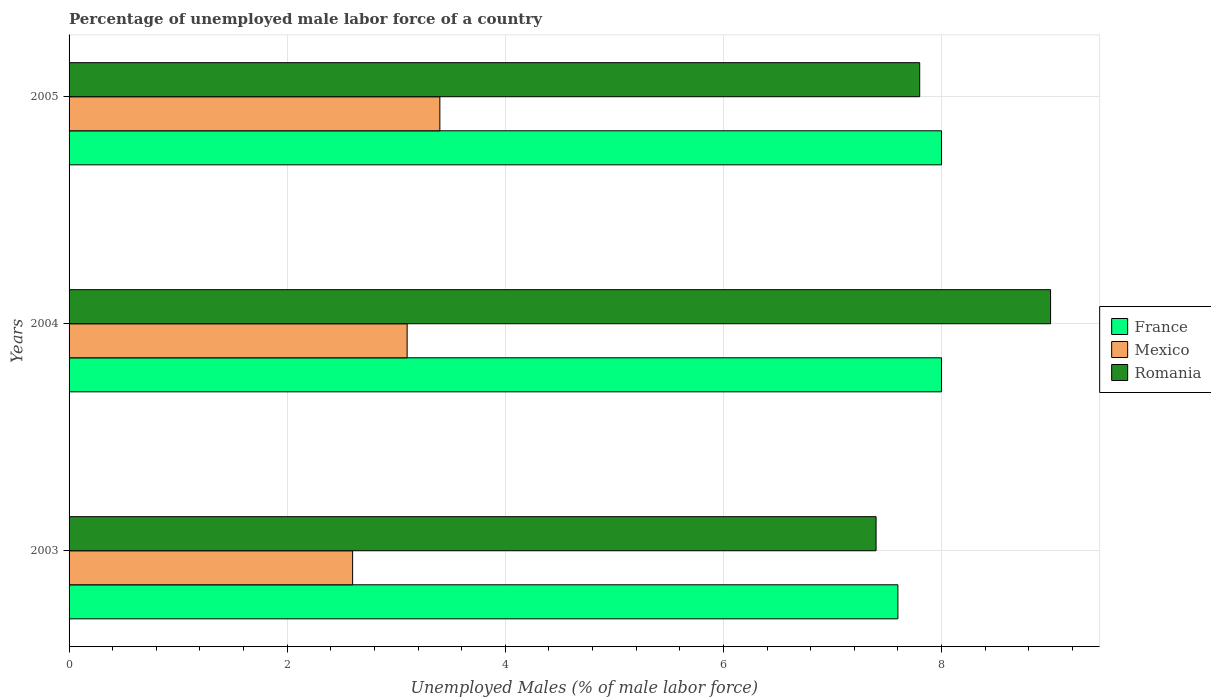How many different coloured bars are there?
Your answer should be very brief. 3. How many groups of bars are there?
Your response must be concise. 3. Are the number of bars per tick equal to the number of legend labels?
Your response must be concise. Yes. Are the number of bars on each tick of the Y-axis equal?
Give a very brief answer. Yes. In how many cases, is the number of bars for a given year not equal to the number of legend labels?
Offer a terse response. 0. What is the percentage of unemployed male labor force in Mexico in 2003?
Your answer should be compact. 2.6. Across all years, what is the minimum percentage of unemployed male labor force in Mexico?
Offer a very short reply. 2.6. In which year was the percentage of unemployed male labor force in Mexico maximum?
Keep it short and to the point. 2005. In which year was the percentage of unemployed male labor force in France minimum?
Your response must be concise. 2003. What is the total percentage of unemployed male labor force in France in the graph?
Ensure brevity in your answer.  23.6. What is the difference between the percentage of unemployed male labor force in Mexico in 2003 and that in 2005?
Your response must be concise. -0.8. What is the difference between the percentage of unemployed male labor force in Mexico in 2004 and the percentage of unemployed male labor force in Romania in 2003?
Keep it short and to the point. -4.3. What is the average percentage of unemployed male labor force in Mexico per year?
Offer a very short reply. 3.03. In the year 2005, what is the difference between the percentage of unemployed male labor force in Romania and percentage of unemployed male labor force in Mexico?
Offer a terse response. 4.4. In how many years, is the percentage of unemployed male labor force in France greater than 7.6 %?
Offer a terse response. 2. What is the ratio of the percentage of unemployed male labor force in France in 2003 to that in 2004?
Ensure brevity in your answer.  0.95. Is the percentage of unemployed male labor force in Mexico in 2003 less than that in 2004?
Ensure brevity in your answer.  Yes. What is the difference between the highest and the second highest percentage of unemployed male labor force in Romania?
Offer a very short reply. 1.2. What is the difference between the highest and the lowest percentage of unemployed male labor force in Mexico?
Ensure brevity in your answer.  0.8. In how many years, is the percentage of unemployed male labor force in Mexico greater than the average percentage of unemployed male labor force in Mexico taken over all years?
Give a very brief answer. 2. What does the 1st bar from the top in 2005 represents?
Provide a short and direct response. Romania. What does the 2nd bar from the bottom in 2005 represents?
Your answer should be compact. Mexico. Are all the bars in the graph horizontal?
Your answer should be compact. Yes. Are the values on the major ticks of X-axis written in scientific E-notation?
Provide a succinct answer. No. Does the graph contain grids?
Ensure brevity in your answer.  Yes. How many legend labels are there?
Keep it short and to the point. 3. How are the legend labels stacked?
Your response must be concise. Vertical. What is the title of the graph?
Provide a succinct answer. Percentage of unemployed male labor force of a country. What is the label or title of the X-axis?
Your answer should be very brief. Unemployed Males (% of male labor force). What is the label or title of the Y-axis?
Keep it short and to the point. Years. What is the Unemployed Males (% of male labor force) in France in 2003?
Your answer should be very brief. 7.6. What is the Unemployed Males (% of male labor force) in Mexico in 2003?
Keep it short and to the point. 2.6. What is the Unemployed Males (% of male labor force) in Romania in 2003?
Provide a succinct answer. 7.4. What is the Unemployed Males (% of male labor force) of France in 2004?
Give a very brief answer. 8. What is the Unemployed Males (% of male labor force) in Mexico in 2004?
Keep it short and to the point. 3.1. What is the Unemployed Males (% of male labor force) of France in 2005?
Your answer should be compact. 8. What is the Unemployed Males (% of male labor force) in Mexico in 2005?
Keep it short and to the point. 3.4. What is the Unemployed Males (% of male labor force) in Romania in 2005?
Your response must be concise. 7.8. Across all years, what is the maximum Unemployed Males (% of male labor force) in Mexico?
Ensure brevity in your answer.  3.4. Across all years, what is the maximum Unemployed Males (% of male labor force) in Romania?
Your answer should be very brief. 9. Across all years, what is the minimum Unemployed Males (% of male labor force) in France?
Provide a succinct answer. 7.6. Across all years, what is the minimum Unemployed Males (% of male labor force) of Mexico?
Your response must be concise. 2.6. Across all years, what is the minimum Unemployed Males (% of male labor force) in Romania?
Your response must be concise. 7.4. What is the total Unemployed Males (% of male labor force) in France in the graph?
Your answer should be compact. 23.6. What is the total Unemployed Males (% of male labor force) in Romania in the graph?
Provide a short and direct response. 24.2. What is the difference between the Unemployed Males (% of male labor force) in Mexico in 2003 and that in 2004?
Offer a very short reply. -0.5. What is the difference between the Unemployed Males (% of male labor force) of France in 2003 and that in 2005?
Keep it short and to the point. -0.4. What is the difference between the Unemployed Males (% of male labor force) in France in 2004 and that in 2005?
Your answer should be compact. 0. What is the difference between the Unemployed Males (% of male labor force) in Mexico in 2004 and that in 2005?
Provide a short and direct response. -0.3. What is the difference between the Unemployed Males (% of male labor force) of Romania in 2004 and that in 2005?
Make the answer very short. 1.2. What is the difference between the Unemployed Males (% of male labor force) of France in 2003 and the Unemployed Males (% of male labor force) of Mexico in 2004?
Make the answer very short. 4.5. What is the difference between the Unemployed Males (% of male labor force) in Mexico in 2003 and the Unemployed Males (% of male labor force) in Romania in 2004?
Ensure brevity in your answer.  -6.4. What is the difference between the Unemployed Males (% of male labor force) of France in 2003 and the Unemployed Males (% of male labor force) of Mexico in 2005?
Offer a terse response. 4.2. What is the difference between the Unemployed Males (% of male labor force) in France in 2004 and the Unemployed Males (% of male labor force) in Romania in 2005?
Give a very brief answer. 0.2. What is the average Unemployed Males (% of male labor force) of France per year?
Your answer should be very brief. 7.87. What is the average Unemployed Males (% of male labor force) in Mexico per year?
Provide a succinct answer. 3.03. What is the average Unemployed Males (% of male labor force) in Romania per year?
Offer a terse response. 8.07. In the year 2003, what is the difference between the Unemployed Males (% of male labor force) in France and Unemployed Males (% of male labor force) in Mexico?
Ensure brevity in your answer.  5. In the year 2003, what is the difference between the Unemployed Males (% of male labor force) of France and Unemployed Males (% of male labor force) of Romania?
Ensure brevity in your answer.  0.2. In the year 2003, what is the difference between the Unemployed Males (% of male labor force) in Mexico and Unemployed Males (% of male labor force) in Romania?
Provide a succinct answer. -4.8. In the year 2004, what is the difference between the Unemployed Males (% of male labor force) of France and Unemployed Males (% of male labor force) of Mexico?
Your response must be concise. 4.9. In the year 2004, what is the difference between the Unemployed Males (% of male labor force) in France and Unemployed Males (% of male labor force) in Romania?
Your answer should be compact. -1. In the year 2004, what is the difference between the Unemployed Males (% of male labor force) of Mexico and Unemployed Males (% of male labor force) of Romania?
Offer a terse response. -5.9. In the year 2005, what is the difference between the Unemployed Males (% of male labor force) in France and Unemployed Males (% of male labor force) in Mexico?
Give a very brief answer. 4.6. What is the ratio of the Unemployed Males (% of male labor force) of France in 2003 to that in 2004?
Your answer should be very brief. 0.95. What is the ratio of the Unemployed Males (% of male labor force) in Mexico in 2003 to that in 2004?
Keep it short and to the point. 0.84. What is the ratio of the Unemployed Males (% of male labor force) of Romania in 2003 to that in 2004?
Provide a short and direct response. 0.82. What is the ratio of the Unemployed Males (% of male labor force) of France in 2003 to that in 2005?
Ensure brevity in your answer.  0.95. What is the ratio of the Unemployed Males (% of male labor force) of Mexico in 2003 to that in 2005?
Your answer should be compact. 0.76. What is the ratio of the Unemployed Males (% of male labor force) in Romania in 2003 to that in 2005?
Keep it short and to the point. 0.95. What is the ratio of the Unemployed Males (% of male labor force) in Mexico in 2004 to that in 2005?
Your response must be concise. 0.91. What is the ratio of the Unemployed Males (% of male labor force) in Romania in 2004 to that in 2005?
Your answer should be compact. 1.15. What is the difference between the highest and the second highest Unemployed Males (% of male labor force) in Mexico?
Keep it short and to the point. 0.3. What is the difference between the highest and the lowest Unemployed Males (% of male labor force) in France?
Offer a very short reply. 0.4. What is the difference between the highest and the lowest Unemployed Males (% of male labor force) in Mexico?
Provide a succinct answer. 0.8. 